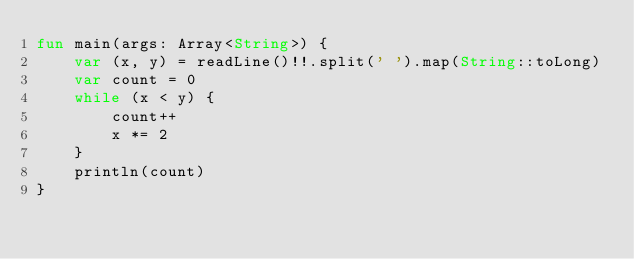<code> <loc_0><loc_0><loc_500><loc_500><_Kotlin_>fun main(args: Array<String>) {
    var (x, y) = readLine()!!.split(' ').map(String::toLong)
    var count = 0
    while (x < y) {
        count++
        x *= 2
    }
    println(count)
}

</code> 